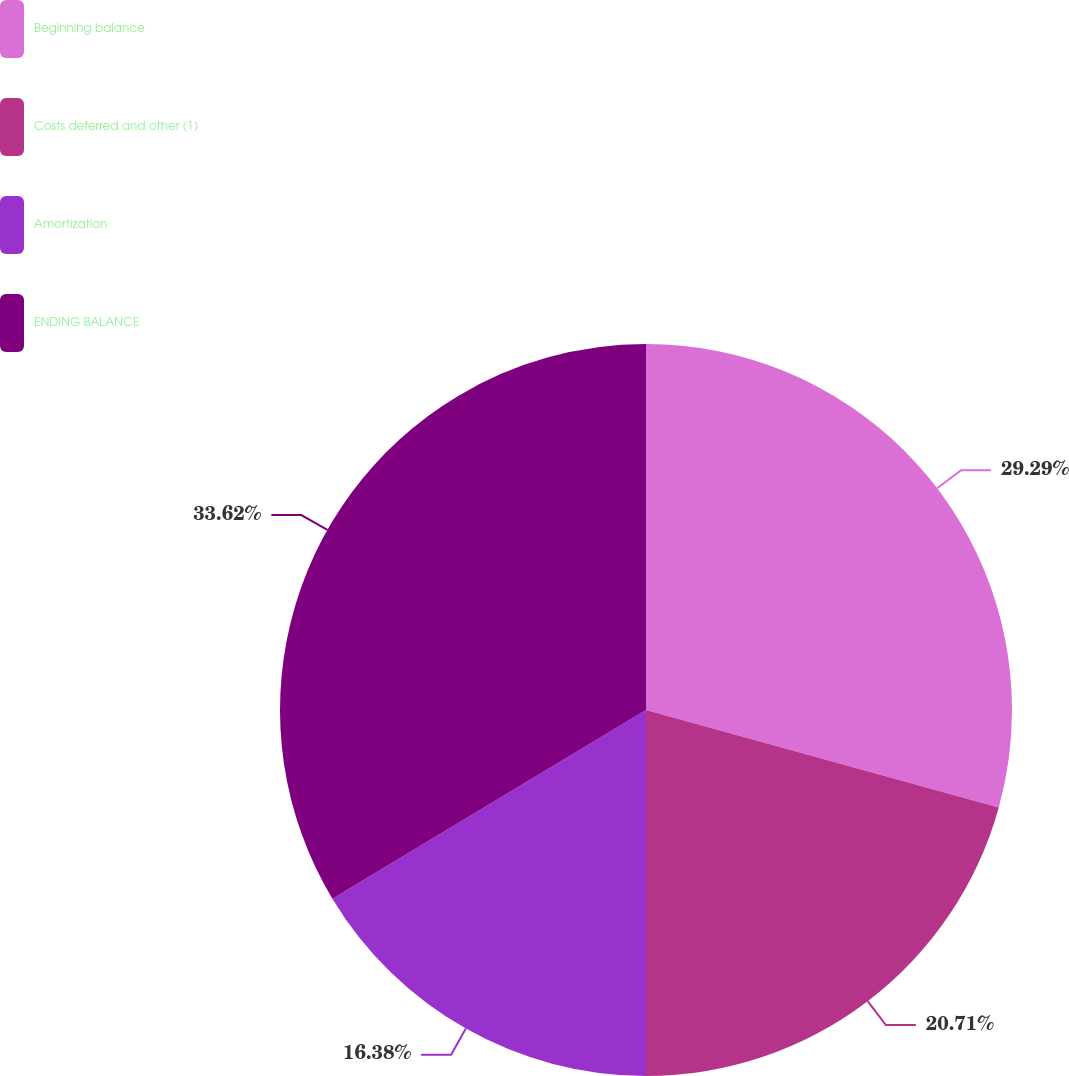<chart> <loc_0><loc_0><loc_500><loc_500><pie_chart><fcel>Beginning balance<fcel>Costs deferred and other (1)<fcel>Amortization<fcel>ENDING BALANCE<nl><fcel>29.29%<fcel>20.71%<fcel>16.38%<fcel>33.62%<nl></chart> 